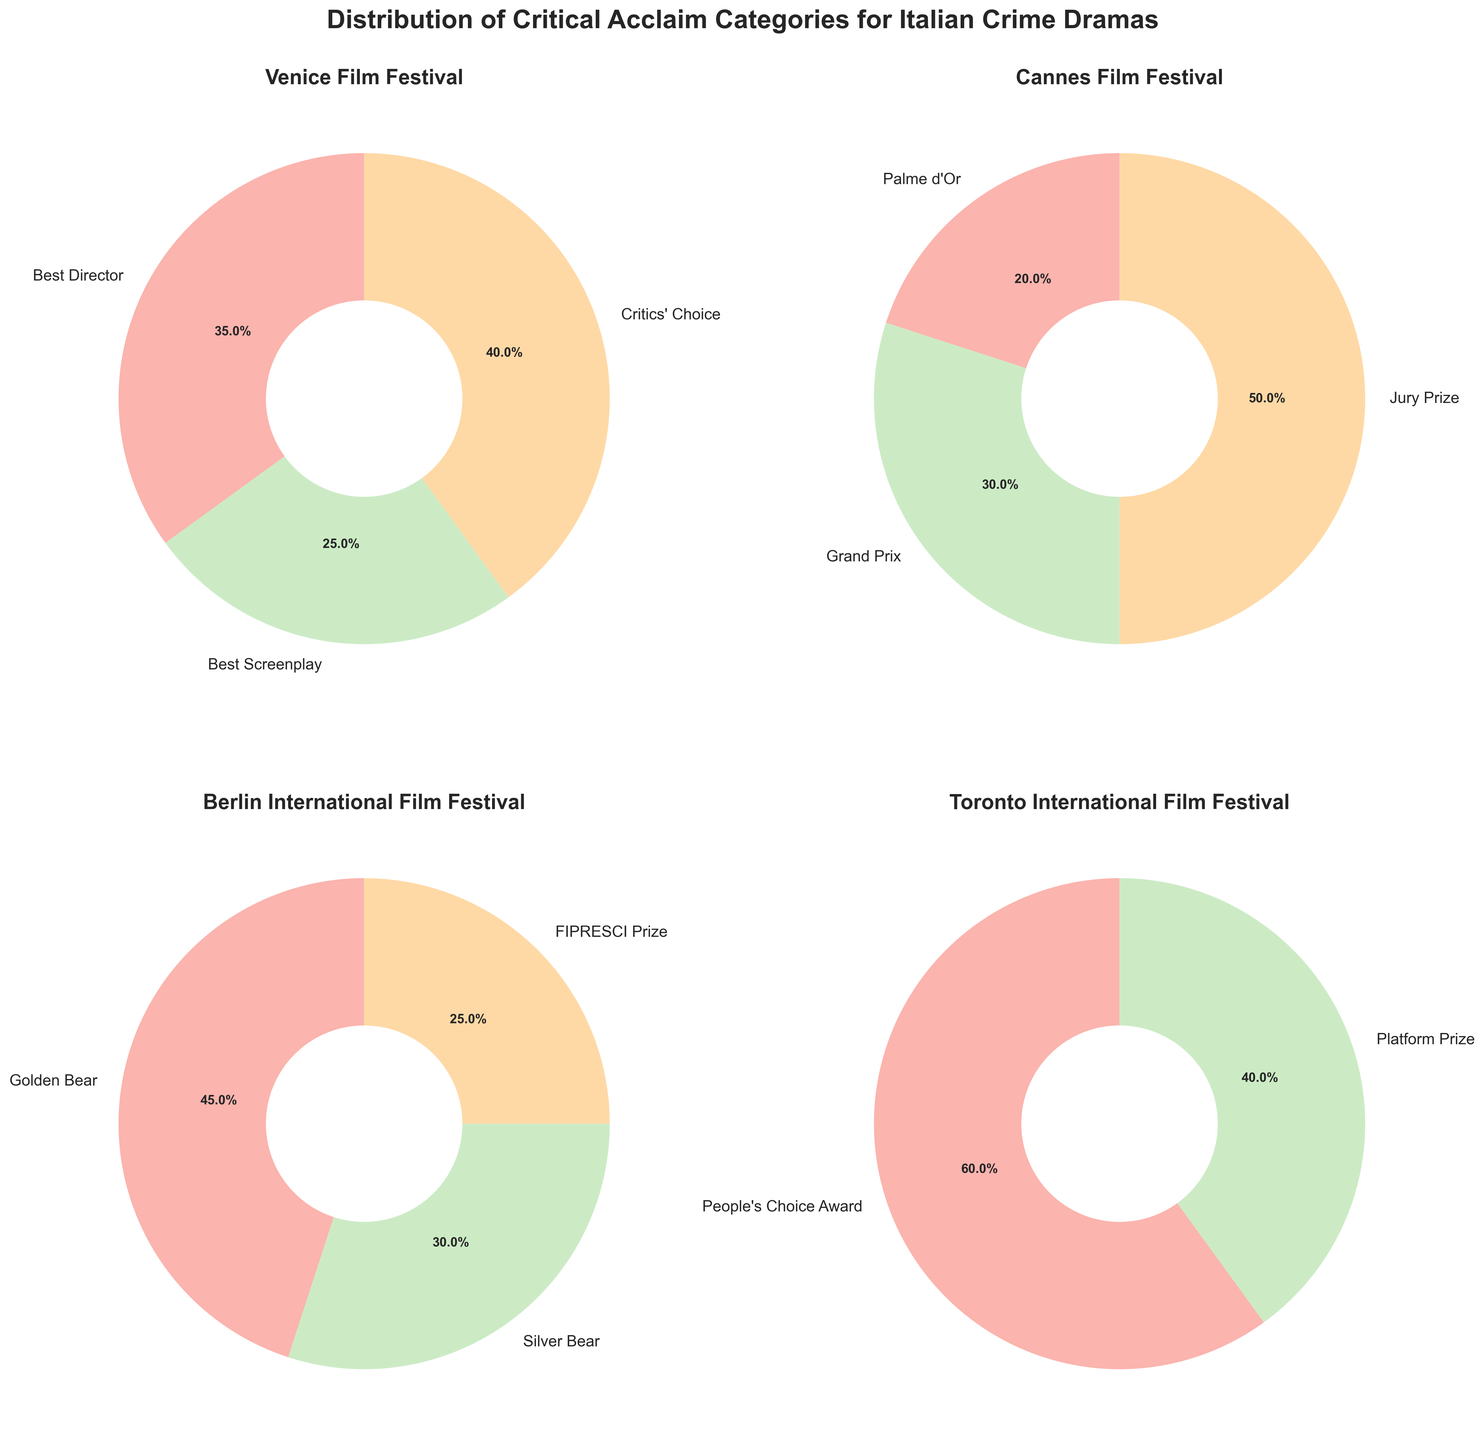Which festival allocates the highest percentage to a single award category? The Toronto International Film Festival gives the People’s Choice Award a 60% allocation, which is the highest percentage for a single category among all the festivals.
Answer: Toronto International Film Festival Which award category has the smallest percentage allocation? Among all the categories in the pie charts, the Palme d'Or at Cannes Film Festival has the smallest percentage at 20%.
Answer: Palme d'Or Compare the percentage allocation for Best Director at the Venice Film Festival and the Golden Bear at the Berlin International Film Festival. Which one is higher? The percentage allocation for Best Director at the Venice Film Festival is 35%, while the Golden Bear at Berlin International Film Festival is allocated 45%. Therefore, the Golden Bear is higher.
Answer: Golden Bear What is the total percentage allocated to the top awards across all festivals (Best Director, Palme d'Or, and Golden Bear)? Adding the percentages: Best Director (Venice) 35% + Palme d'Or (Cannes) 20% + Golden Bear (Berlin) 45% = 100% total.
Answer: 100% Which festival has the most balanced distribution of award categories? The Cannes Film Festival has the most balanced distribution, with the percentages 20%, 30%, and 50% for its three categories.
Answer: Cannes Film Festival What percentage of awards at Berlin International Film Festival goes to the Silver Bear and FIPRESCI Prize combined? Adding the percentages for Silver Bear (30%) and FIPRESCI Prize (25%): 30% + 25% = 55%.
Answer: 55% How many festivals have more than 50% allocation for a single category? The Toronto International Film Festival (People's Choice Award, 60%) and the Berlin International Film Festival (Golden Bear, 45%) do not exceed 50%, while other festivals do. Therefore, only the Toronto International Film Festival exceeds 50% for a single category.
Answer: One Which award category for the Berlin International Film Festival has the smallest allocation? The FIPRESCI Prize at the Berlin International Film Festival has the smallest allocation with 25%.
Answer: FIPRESCI Prize What is the combined percentage for Critics' Choice and Best Screenplay at the Venice Film Festival? Adding the percentages for Critics' Choice (40%) and Best Screenplay (25%): 40% + 25% = 65%.
Answer: 65% 